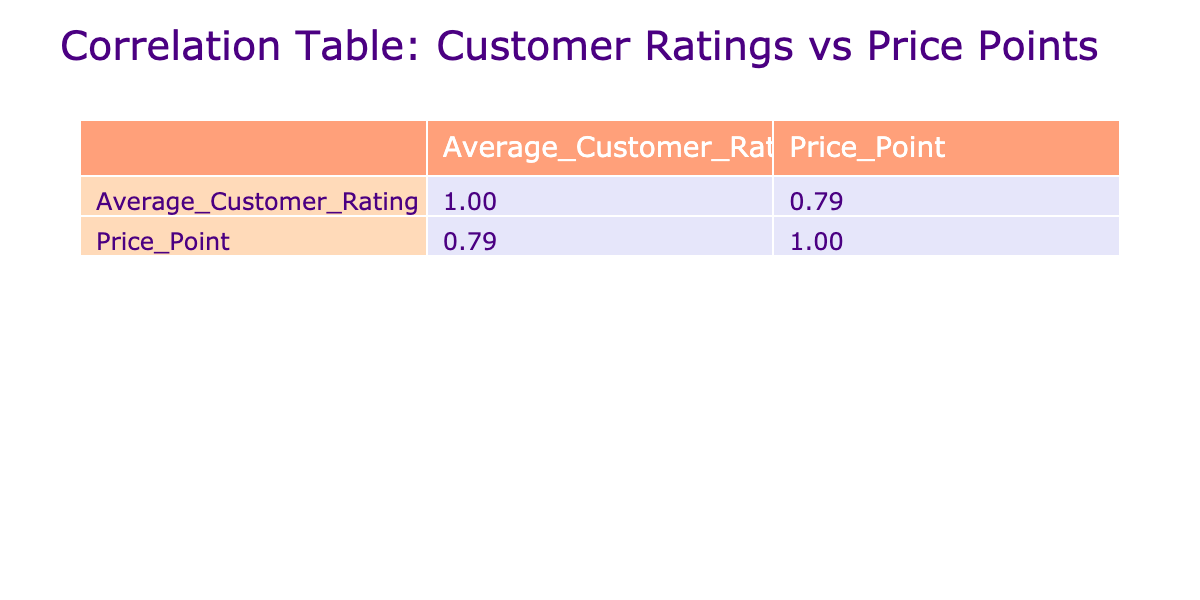What is the average customer rating for Tiramisu? The table lists Tiramisu with an average customer rating of 4.9. This is the specific value that answers the question directly based on the data provided.
Answer: 4.9 Is the average customer rating for Croissant higher than that of Churros? The average rating for Croissant is 4.6, while for Churros it is 4.2. Since 4.6 is greater than 4.2, the statement is true.
Answer: Yes What is the price point of the pastry with the highest average rating? The highest average rating is 4.9 for Tiramisu, and the table shows that its price point is 5.50. Hence, this is the value we are looking for.
Answer: 5.50 Calculate the difference in average customer ratings between Baklava and Eclair. Baklava has a rating of 4.5 and Eclair has a rating of 4.7. The difference is calculated as 4.7 - 4.5 = 0.2. This gives us the answer for the difference in ratings.
Answer: 0.2 Does Gulab Jamun have a lower average rating compared to Macaron? Gulab Jamun has a rating of 4.5 while Macaron has a rating of 4.4. Since 4.5 is greater than 4.4, this statement is false.
Answer: No What is the average customer rating of pastries that have a price point below 3 dollars? The table indicates Churros (1.80) and Macaron (2.00) are below 3 dollars. Their ratings are 4.2 and 4.4 respectively. To find the average, we calculate (4.2 + 4.4) / 2 = 4.3. Thus, we provide the average rating for these specific pastries.
Answer: 4.3 What is the correlation coefficient between average customer ratings and price points? Looking at the correlation values in the table, the correlation coefficient for average customer ratings and price points is indicated as approximately -0.50, implying a moderate negative correlation.
Answer: -0.50 Which pastry has the lowest customer rating, and what is its price point? From the table, Scone has the lowest average rating of 4.1. The corresponding price point for Scone is 2.80. This answer combines the data for both metrics based on the listing in the table.
Answer: 2.80 Is there a direct correlation between higher price points and higher average customer ratings in the data? The correlation coefficient of -0.50 suggests a moderate negative correlation, indicating that as price points increase, the average ratings may decrease. Thus, it is true there isn't a direct correlation.
Answer: No 